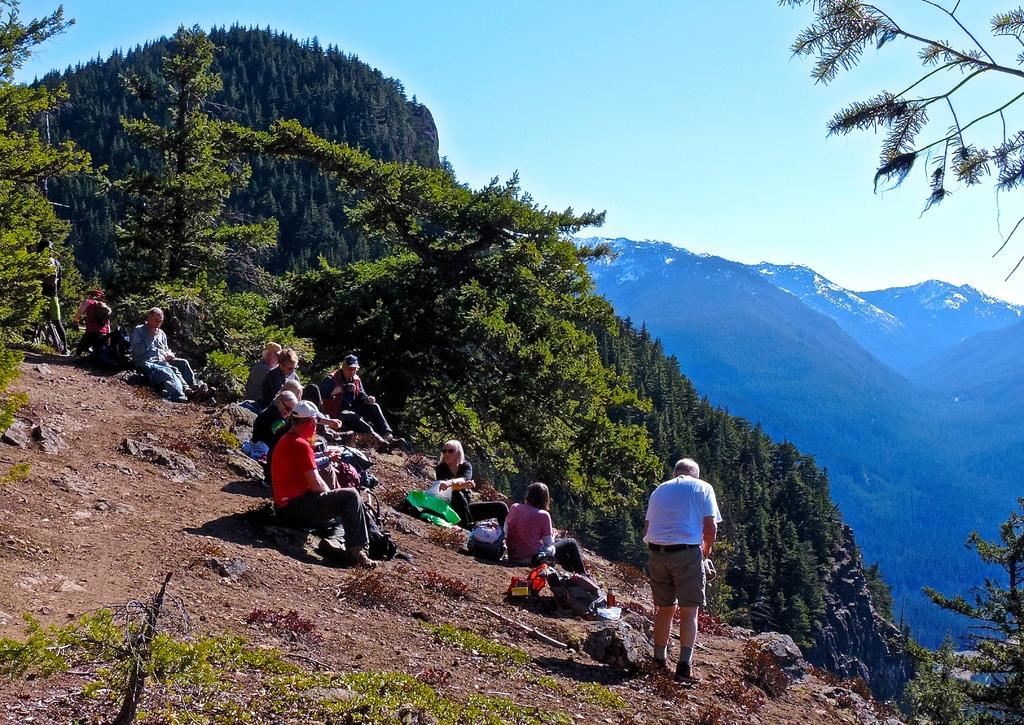What are the people in the image doing? The people in the image are sitting on a rock. Can you describe the man in the image? There is a man standing in the image. What can be seen in the background of the image? There are trees and mountains in the background of the image. What type of stew is being prepared by the people sitting on the rock in the image? There is no indication in the image that the people are preparing or eating any stew. 